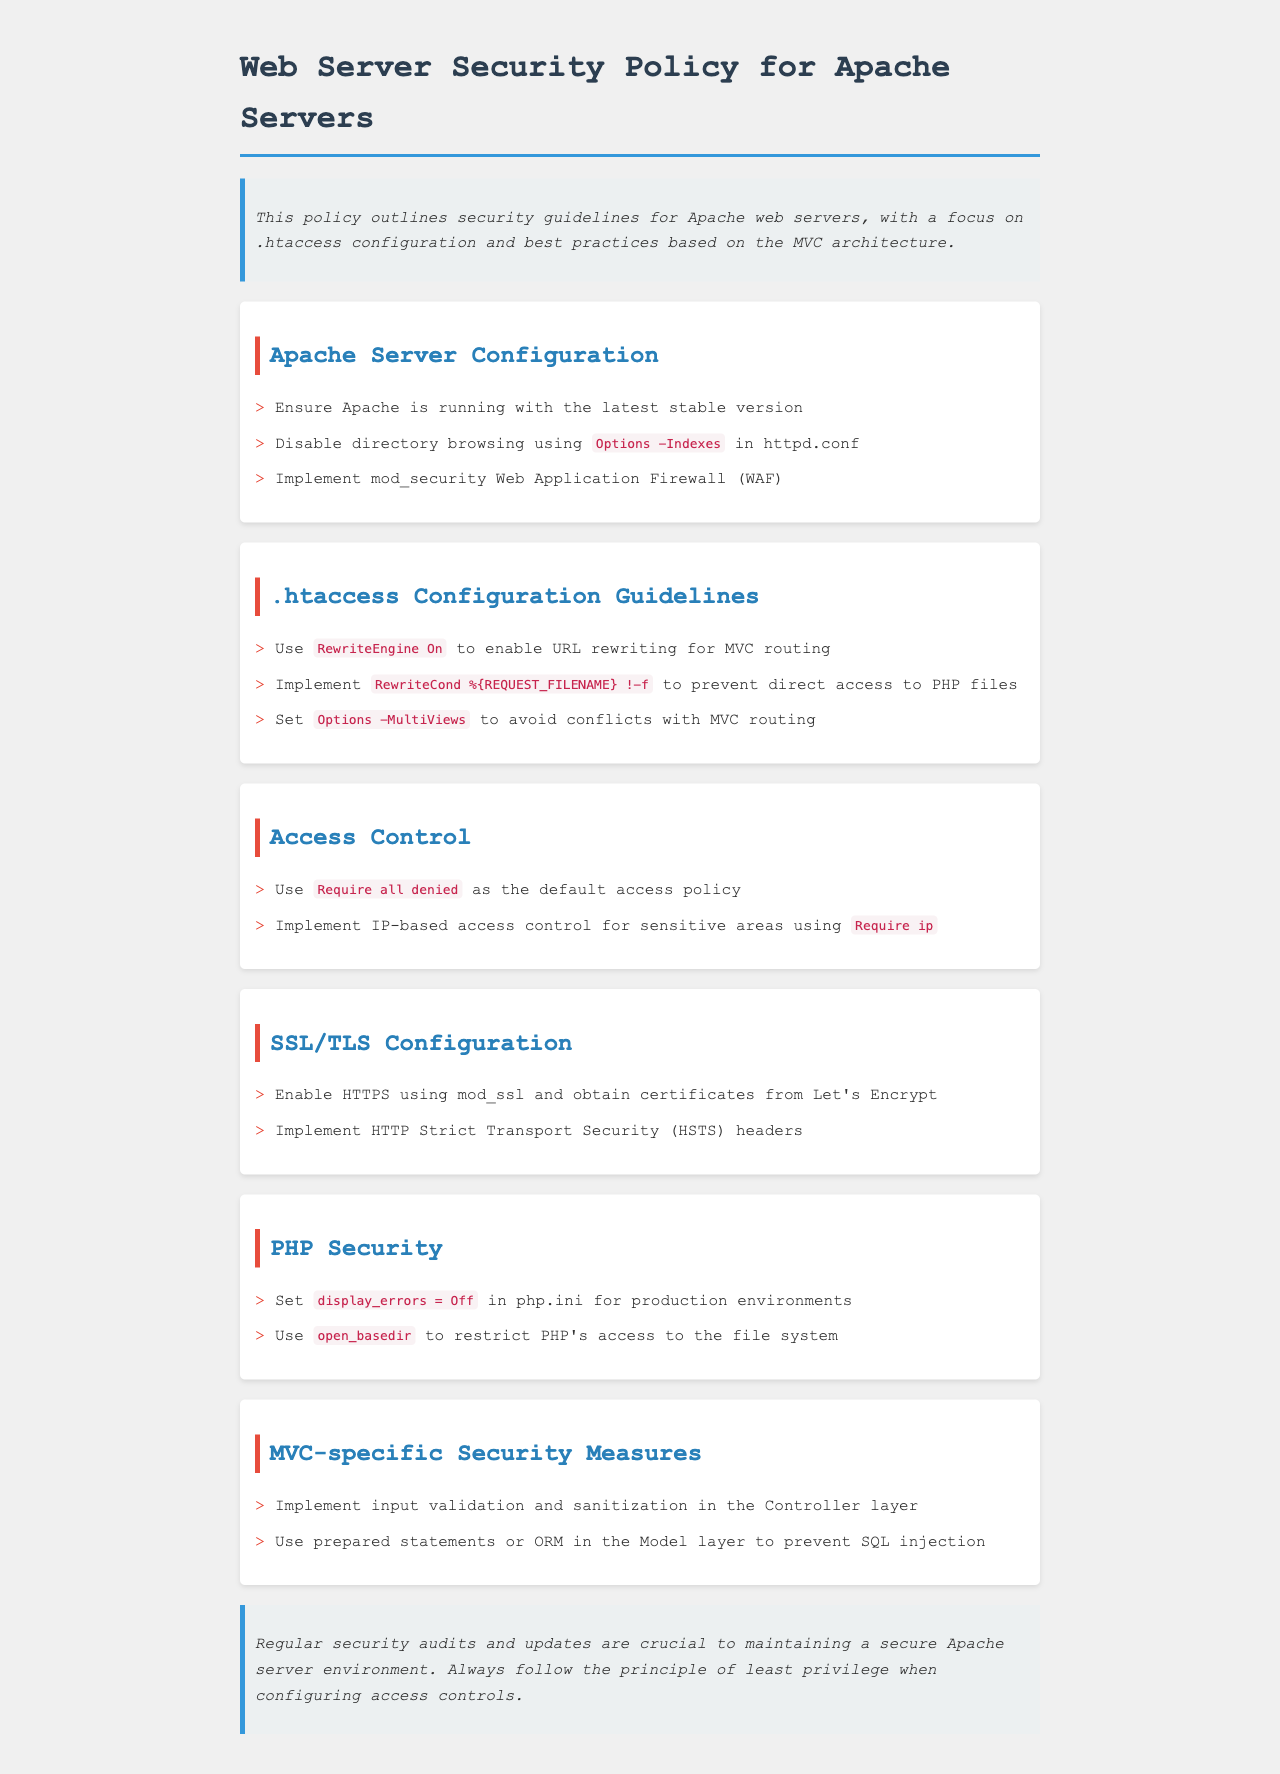what should the default access policy be? The document states that the default access policy should be set using the directive "Require all denied".
Answer: Require all denied what should be enabled for URL rewriting in .htaccess? The document states that "RewriteEngine On" should be implemented to enable URL rewriting.
Answer: RewriteEngine On what is recommended for HTTPS configuration? The document recommends enabling HTTPS using mod_ssl and obtaining certificates from Let's Encrypt.
Answer: mod_ssl, Let's Encrypt which setting should be turned off in php.ini for production? The document advises setting "display_errors" to off for production environments.
Answer: display_errors = Off what is a security measure in MVC for input? The document suggests implementing input validation and sanitization in the Controller layer.
Answer: input validation and sanitization which Apache directive should be used to disable directory browsing? The document recommends using "Options -Indexes" in httpd.conf to disable directory browsing.
Answer: Options -Indexes how often should security audits be conducted? The conclusion implies that regular security audits are crucial, indicating they should be conducted frequently.
Answer: Regularly what does HSTS stand for? The document mentions implementing HTTP Strict Transport Security headers, thus HSTS stands for that term.
Answer: HTTP Strict Transport Security what should be used in the Model layer to prevent SQL injection? The document states that using prepared statements or ORM in the Model layer helps prevent SQL injection.
Answer: prepared statements or ORM 